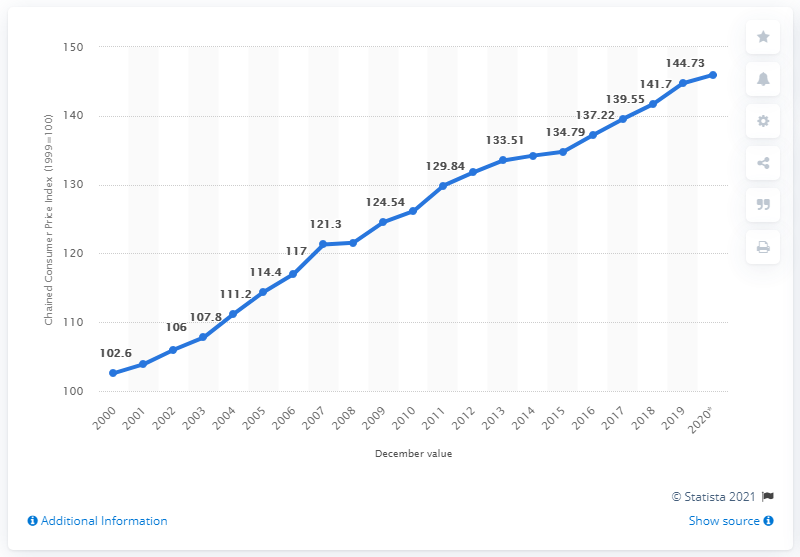Mention a couple of crucial points in this snapshot. The chained consumer price index in December 2020 was 145.94. 